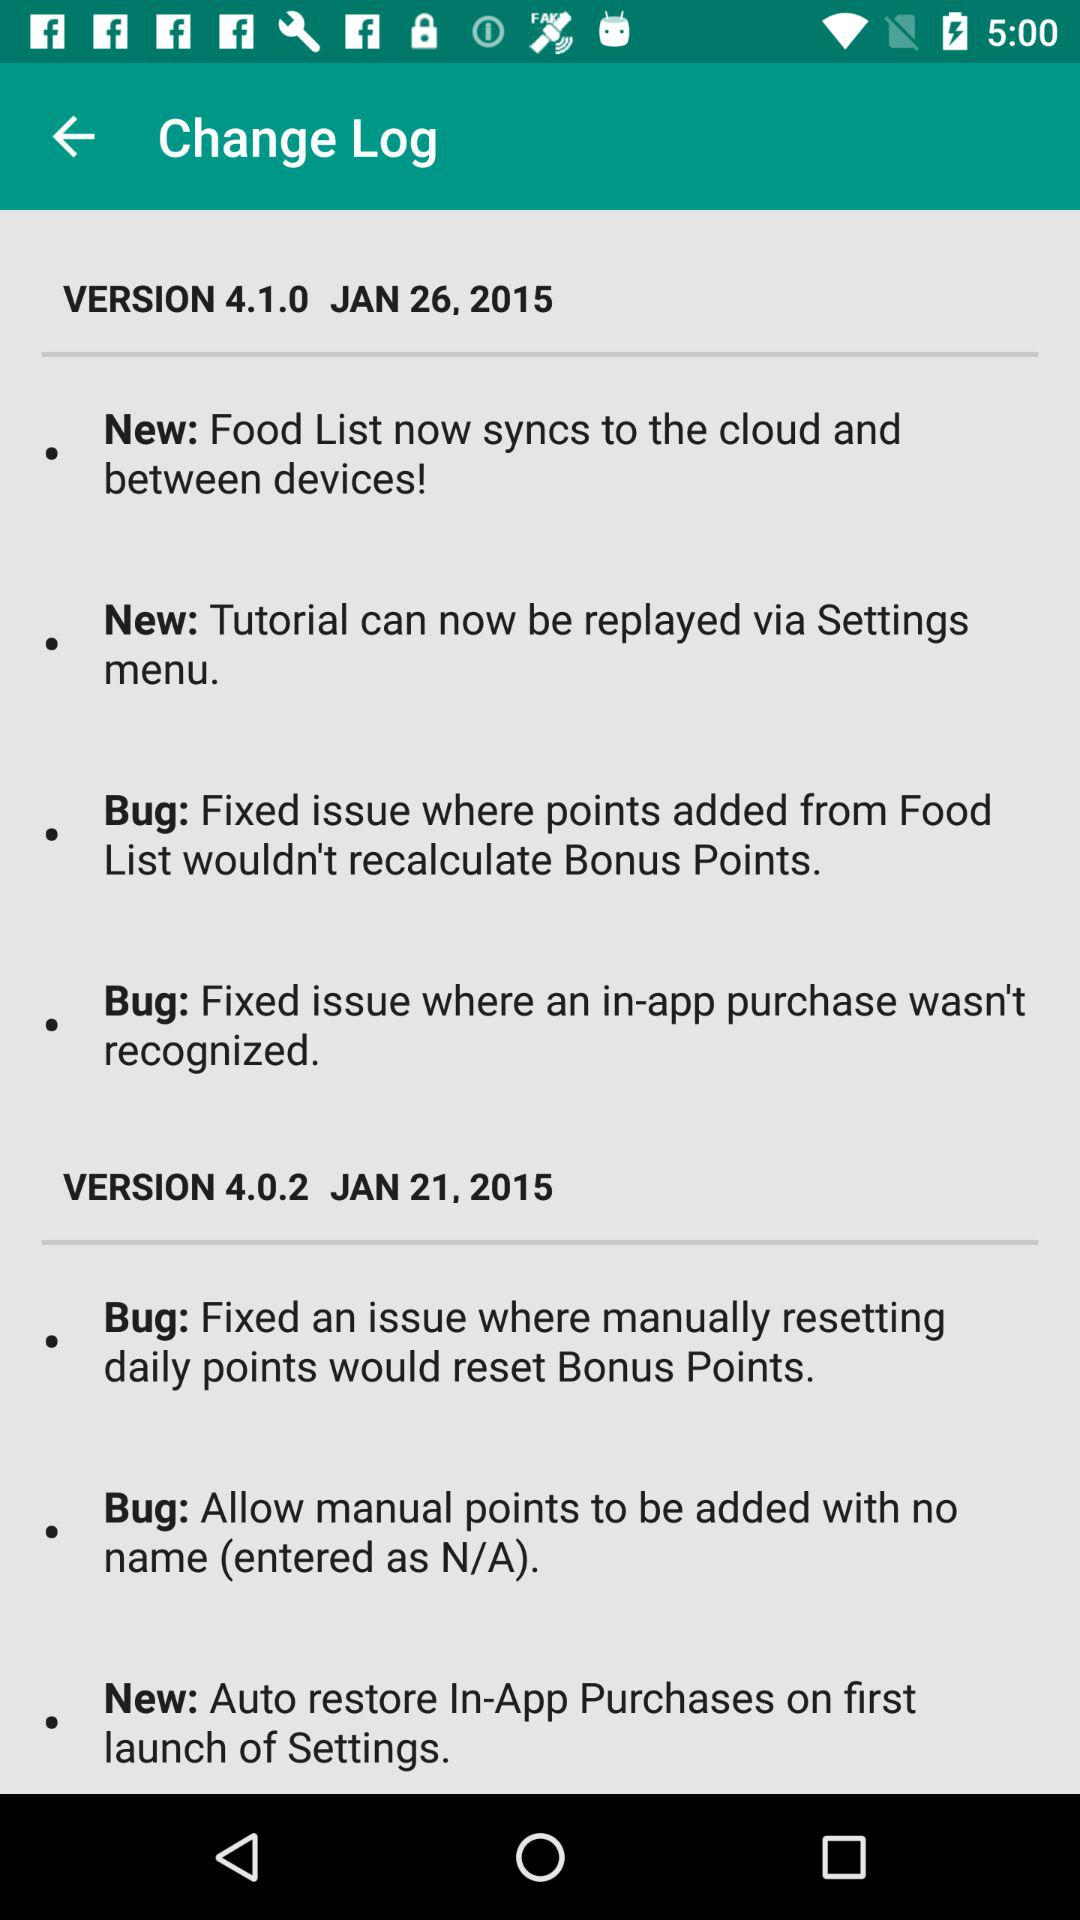Which version of application is used?
When the provided information is insufficient, respond with <no answer>. <no answer> 